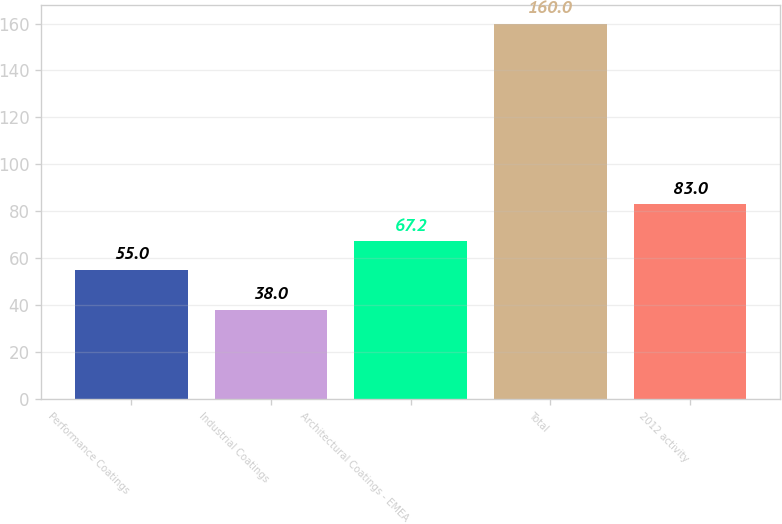<chart> <loc_0><loc_0><loc_500><loc_500><bar_chart><fcel>Performance Coatings<fcel>Industrial Coatings<fcel>Architectural Coatings - EMEA<fcel>Total<fcel>2012 activity<nl><fcel>55<fcel>38<fcel>67.2<fcel>160<fcel>83<nl></chart> 